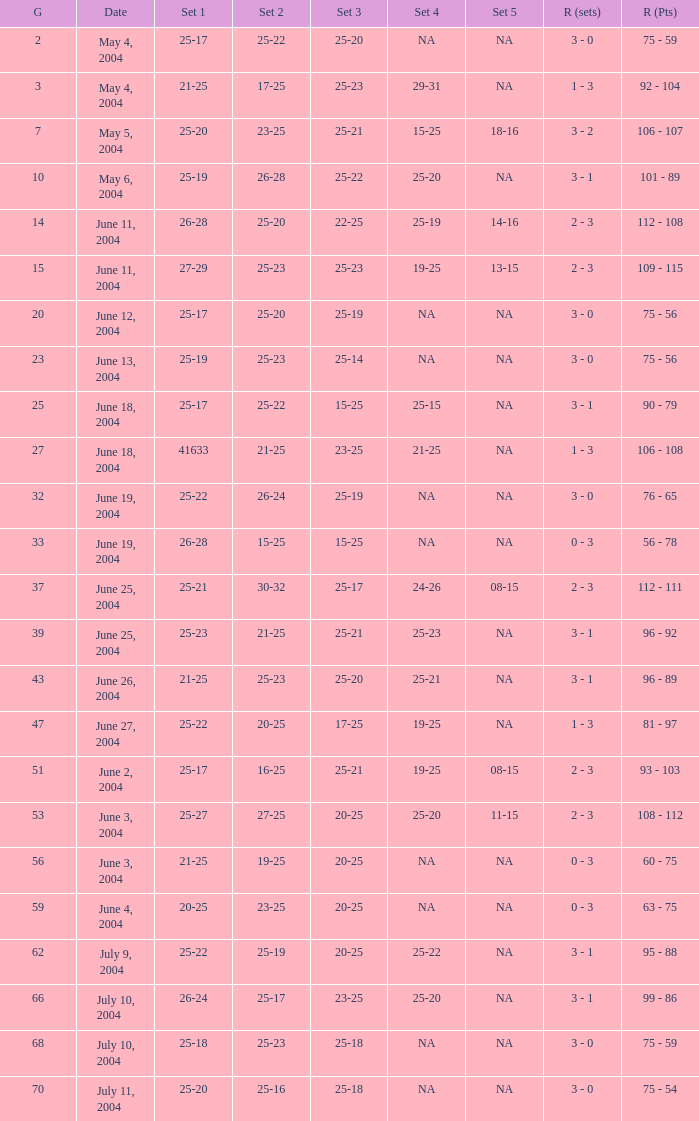What is the set 5 for the game with a set 2 of 21-25 and a set 1 of 41633? NA. 